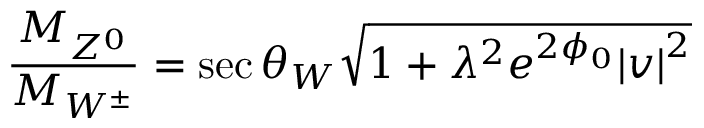<formula> <loc_0><loc_0><loc_500><loc_500>\frac { M _ { Z ^ { 0 } } } { M _ { W ^ { \pm } } } = \sec \theta _ { W } \sqrt { 1 + { \lambda } ^ { 2 } e ^ { 2 \phi _ { 0 } } { | v | } ^ { 2 } }</formula> 